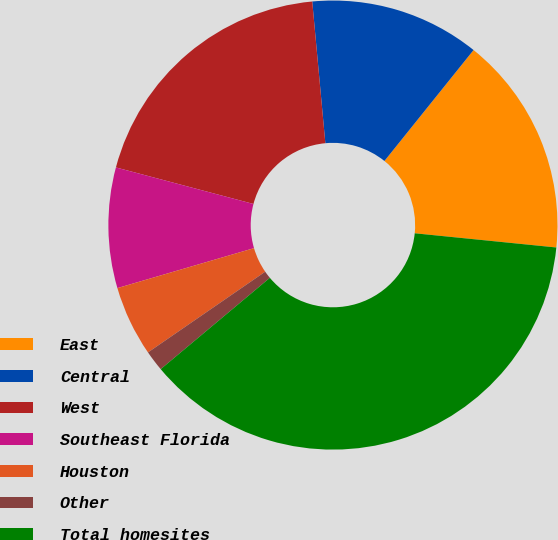Convert chart. <chart><loc_0><loc_0><loc_500><loc_500><pie_chart><fcel>East<fcel>Central<fcel>West<fcel>Southeast Florida<fcel>Houston<fcel>Other<fcel>Total homesites<nl><fcel>15.82%<fcel>12.24%<fcel>19.4%<fcel>8.66%<fcel>5.07%<fcel>1.49%<fcel>37.32%<nl></chart> 